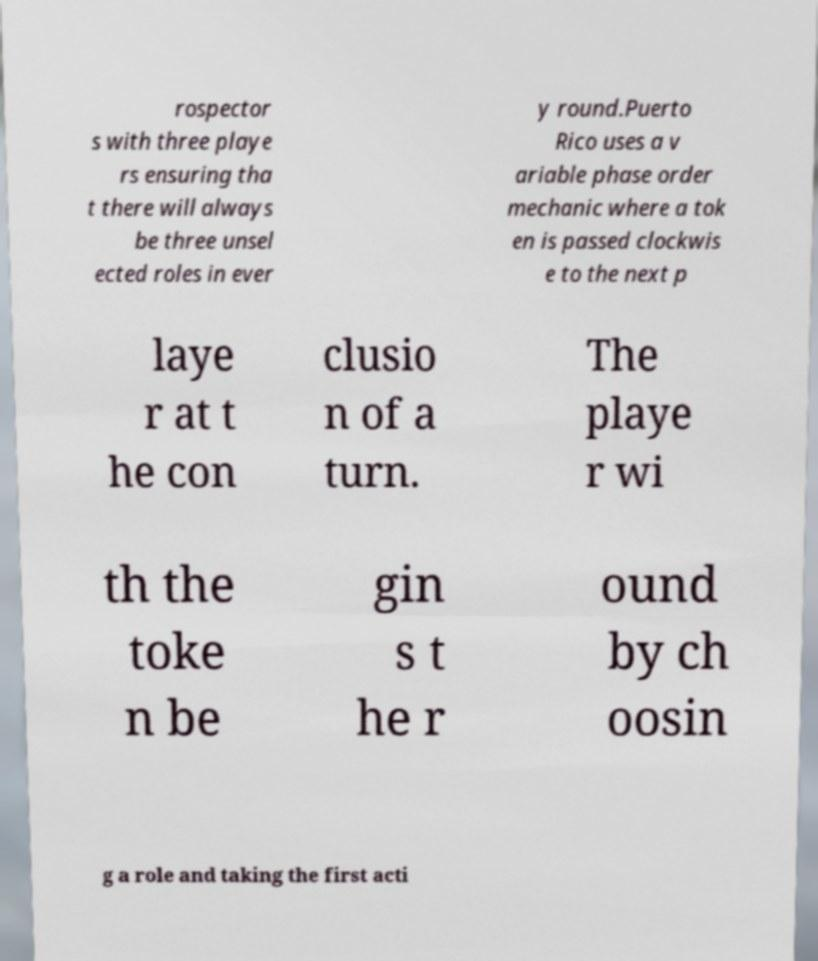I need the written content from this picture converted into text. Can you do that? rospector s with three playe rs ensuring tha t there will always be three unsel ected roles in ever y round.Puerto Rico uses a v ariable phase order mechanic where a tok en is passed clockwis e to the next p laye r at t he con clusio n of a turn. The playe r wi th the toke n be gin s t he r ound by ch oosin g a role and taking the first acti 